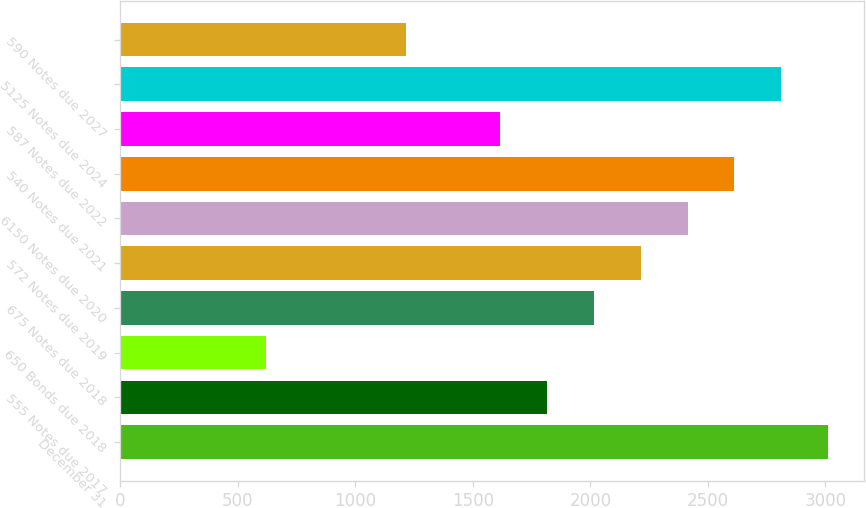Convert chart. <chart><loc_0><loc_0><loc_500><loc_500><bar_chart><fcel>December 31<fcel>555 Notes due 2017<fcel>650 Bonds due 2018<fcel>675 Notes due 2018<fcel>572 Notes due 2019<fcel>6150 Notes due 2020<fcel>540 Notes due 2021<fcel>587 Notes due 2022<fcel>5125 Notes due 2024<fcel>590 Notes due 2027<nl><fcel>3012<fcel>1815.6<fcel>619.2<fcel>2015<fcel>2214.4<fcel>2413.8<fcel>2613.2<fcel>1616.2<fcel>2812.6<fcel>1217.4<nl></chart> 